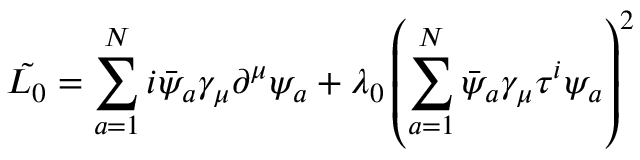<formula> <loc_0><loc_0><loc_500><loc_500>\tilde { L _ { 0 } } = \sum _ { a = 1 } ^ { N } i \bar { \psi } _ { a } \gamma _ { \mu } \partial ^ { \mu } \psi _ { a } + \lambda _ { 0 } \left ( \sum _ { a = 1 } ^ { N } \bar { \psi } _ { a } \gamma _ { \mu } \tau ^ { i } \psi _ { a } \right ) ^ { 2 }</formula> 